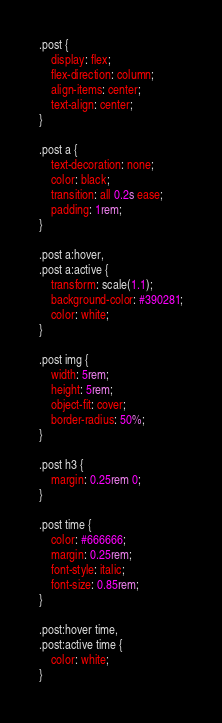<code> <loc_0><loc_0><loc_500><loc_500><_CSS_>.post {
    display: flex;
    flex-direction: column;
    align-items: center;
    text-align: center;
}

.post a {
    text-decoration: none;
    color: black;
    transition: all 0.2s ease;
    padding: 1rem;
}

.post a:hover,
.post a:active {
    transform: scale(1.1);
    background-color: #390281;
    color: white;
}

.post img {
    width: 5rem;
    height: 5rem;
    object-fit: cover;
    border-radius: 50%;
}

.post h3 {
    margin: 0.25rem 0;
}

.post time {
    color: #666666;
    margin: 0.25rem;
    font-style: italic;
    font-size: 0.85rem;
}

.post:hover time,
.post:active time {
    color: white;
}</code> 